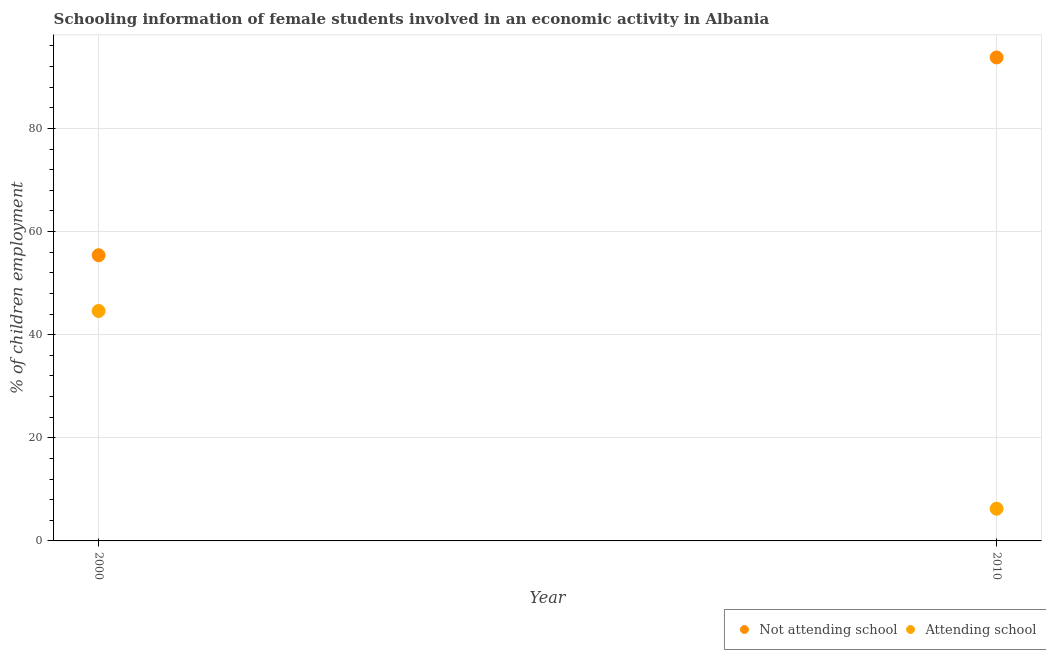How many different coloured dotlines are there?
Your answer should be very brief. 2. Is the number of dotlines equal to the number of legend labels?
Give a very brief answer. Yes. What is the percentage of employed females who are not attending school in 2010?
Your answer should be very brief. 93.76. Across all years, what is the maximum percentage of employed females who are not attending school?
Your response must be concise. 93.76. Across all years, what is the minimum percentage of employed females who are not attending school?
Give a very brief answer. 55.41. What is the total percentage of employed females who are not attending school in the graph?
Ensure brevity in your answer.  149.17. What is the difference between the percentage of employed females who are attending school in 2000 and that in 2010?
Make the answer very short. 38.35. What is the difference between the percentage of employed females who are attending school in 2010 and the percentage of employed females who are not attending school in 2000?
Ensure brevity in your answer.  -49.17. What is the average percentage of employed females who are attending school per year?
Offer a terse response. 25.42. In the year 2000, what is the difference between the percentage of employed females who are attending school and percentage of employed females who are not attending school?
Your answer should be compact. -10.82. In how many years, is the percentage of employed females who are not attending school greater than 32 %?
Your response must be concise. 2. What is the ratio of the percentage of employed females who are not attending school in 2000 to that in 2010?
Offer a terse response. 0.59. Is the percentage of employed females who are not attending school in 2000 less than that in 2010?
Your response must be concise. Yes. In how many years, is the percentage of employed females who are attending school greater than the average percentage of employed females who are attending school taken over all years?
Ensure brevity in your answer.  1. Does the percentage of employed females who are not attending school monotonically increase over the years?
Keep it short and to the point. Yes. Is the percentage of employed females who are not attending school strictly greater than the percentage of employed females who are attending school over the years?
Offer a terse response. Yes. How many dotlines are there?
Offer a very short reply. 2. How many years are there in the graph?
Give a very brief answer. 2. What is the difference between two consecutive major ticks on the Y-axis?
Give a very brief answer. 20. Are the values on the major ticks of Y-axis written in scientific E-notation?
Your answer should be compact. No. Does the graph contain grids?
Ensure brevity in your answer.  Yes. Where does the legend appear in the graph?
Offer a terse response. Bottom right. What is the title of the graph?
Offer a terse response. Schooling information of female students involved in an economic activity in Albania. Does "Net National savings" appear as one of the legend labels in the graph?
Provide a succinct answer. No. What is the label or title of the X-axis?
Your answer should be very brief. Year. What is the label or title of the Y-axis?
Provide a short and direct response. % of children employment. What is the % of children employment in Not attending school in 2000?
Offer a terse response. 55.41. What is the % of children employment of Attending school in 2000?
Give a very brief answer. 44.59. What is the % of children employment in Not attending school in 2010?
Your answer should be compact. 93.76. What is the % of children employment of Attending school in 2010?
Offer a terse response. 6.24. Across all years, what is the maximum % of children employment of Not attending school?
Offer a terse response. 93.76. Across all years, what is the maximum % of children employment in Attending school?
Your answer should be compact. 44.59. Across all years, what is the minimum % of children employment of Not attending school?
Ensure brevity in your answer.  55.41. Across all years, what is the minimum % of children employment in Attending school?
Your response must be concise. 6.24. What is the total % of children employment of Not attending school in the graph?
Provide a short and direct response. 149.17. What is the total % of children employment in Attending school in the graph?
Provide a short and direct response. 50.83. What is the difference between the % of children employment of Not attending school in 2000 and that in 2010?
Your answer should be compact. -38.35. What is the difference between the % of children employment of Attending school in 2000 and that in 2010?
Provide a succinct answer. 38.35. What is the difference between the % of children employment of Not attending school in 2000 and the % of children employment of Attending school in 2010?
Give a very brief answer. 49.17. What is the average % of children employment of Not attending school per year?
Your response must be concise. 74.58. What is the average % of children employment in Attending school per year?
Make the answer very short. 25.42. In the year 2000, what is the difference between the % of children employment of Not attending school and % of children employment of Attending school?
Give a very brief answer. 10.81. In the year 2010, what is the difference between the % of children employment of Not attending school and % of children employment of Attending school?
Ensure brevity in your answer.  87.52. What is the ratio of the % of children employment in Not attending school in 2000 to that in 2010?
Provide a short and direct response. 0.59. What is the ratio of the % of children employment in Attending school in 2000 to that in 2010?
Your response must be concise. 7.14. What is the difference between the highest and the second highest % of children employment of Not attending school?
Ensure brevity in your answer.  38.35. What is the difference between the highest and the second highest % of children employment of Attending school?
Ensure brevity in your answer.  38.35. What is the difference between the highest and the lowest % of children employment in Not attending school?
Your answer should be compact. 38.35. What is the difference between the highest and the lowest % of children employment in Attending school?
Offer a very short reply. 38.35. 